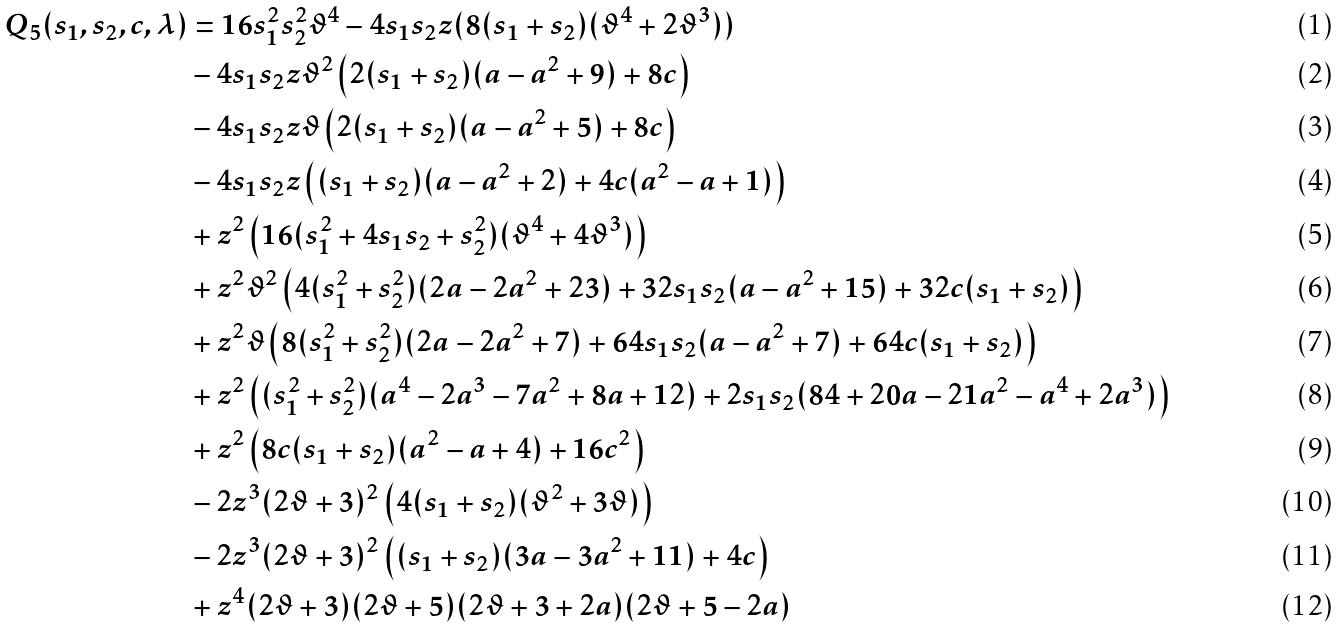Convert formula to latex. <formula><loc_0><loc_0><loc_500><loc_500>Q _ { 5 } ( s _ { 1 } , s _ { 2 } , c , \lambda ) & = 1 6 s _ { 1 } ^ { 2 } s _ { 2 } ^ { 2 } \vartheta ^ { 4 } - 4 s _ { 1 } s _ { 2 } z ( 8 ( s _ { 1 } + s _ { 2 } ) ( \vartheta ^ { 4 } + 2 \vartheta ^ { 3 } ) ) \\ & - 4 s _ { 1 } s _ { 2 } z \vartheta ^ { 2 } \left ( 2 ( s _ { 1 } + s _ { 2 } ) ( a - a ^ { 2 } + 9 ) + 8 c \right ) \\ & - 4 s _ { 1 } s _ { 2 } z \vartheta \left ( 2 ( s _ { 1 } + s _ { 2 } ) ( a - a ^ { 2 } + 5 ) + 8 c \right ) \\ & - 4 s _ { 1 } s _ { 2 } z \left ( ( s _ { 1 } + s _ { 2 } ) ( a - a ^ { 2 } + 2 ) + 4 c ( a ^ { 2 } - a + 1 ) \right ) \\ & + z ^ { 2 } \left ( 1 6 ( s _ { 1 } ^ { 2 } + 4 s _ { 1 } s _ { 2 } + s _ { 2 } ^ { 2 } ) ( \vartheta ^ { 4 } + 4 \vartheta ^ { 3 } ) \right ) \\ & + z ^ { 2 } \vartheta ^ { 2 } \left ( 4 ( s _ { 1 } ^ { 2 } + s _ { 2 } ^ { 2 } ) ( 2 a - 2 a ^ { 2 } + 2 3 ) + 3 2 s _ { 1 } s _ { 2 } ( a - a ^ { 2 } + 1 5 ) + 3 2 c ( s _ { 1 } + s _ { 2 } ) \right ) \\ & + z ^ { 2 } \vartheta \left ( 8 ( s _ { 1 } ^ { 2 } + s _ { 2 } ^ { 2 } ) ( 2 a - 2 a ^ { 2 } + 7 ) + 6 4 s _ { 1 } s _ { 2 } ( a - a ^ { 2 } + 7 ) + 6 4 c ( s _ { 1 } + s _ { 2 } ) \right ) \\ & + z ^ { 2 } \left ( ( s _ { 1 } ^ { 2 } + s _ { 2 } ^ { 2 } ) ( a ^ { 4 } - 2 a ^ { 3 } - 7 a ^ { 2 } + 8 a + 1 2 ) + 2 s _ { 1 } s _ { 2 } ( 8 4 + 2 0 a - 2 1 a ^ { 2 } - a ^ { 4 } + 2 a ^ { 3 } ) \right ) \\ & + z ^ { 2 } \left ( 8 c ( s _ { 1 } + s _ { 2 } ) ( a ^ { 2 } - a + 4 ) + 1 6 c ^ { 2 } \right ) \\ & - 2 z ^ { 3 } ( 2 \vartheta + 3 ) ^ { 2 } \left ( 4 ( s _ { 1 } + s _ { 2 } ) ( \vartheta ^ { 2 } + 3 \vartheta ) \right ) \\ & - 2 z ^ { 3 } ( 2 \vartheta + 3 ) ^ { 2 } \left ( ( s _ { 1 } + s _ { 2 } ) ( 3 a - 3 a ^ { 2 } + 1 1 ) + 4 c \right ) \\ & + z ^ { 4 } ( 2 \vartheta + 3 ) ( 2 \vartheta + 5 ) ( 2 \vartheta + 3 + 2 a ) ( 2 \vartheta + 5 - 2 a )</formula> 